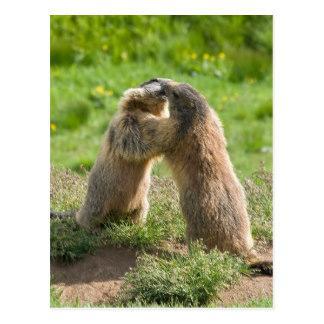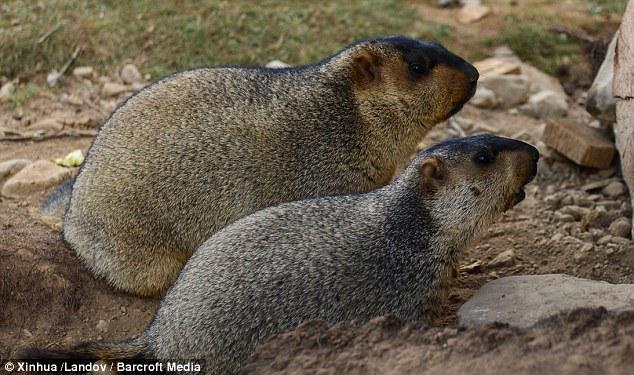The first image is the image on the left, the second image is the image on the right. Evaluate the accuracy of this statement regarding the images: "the marmot is sitting in the grass eating". Is it true? Answer yes or no. No. 